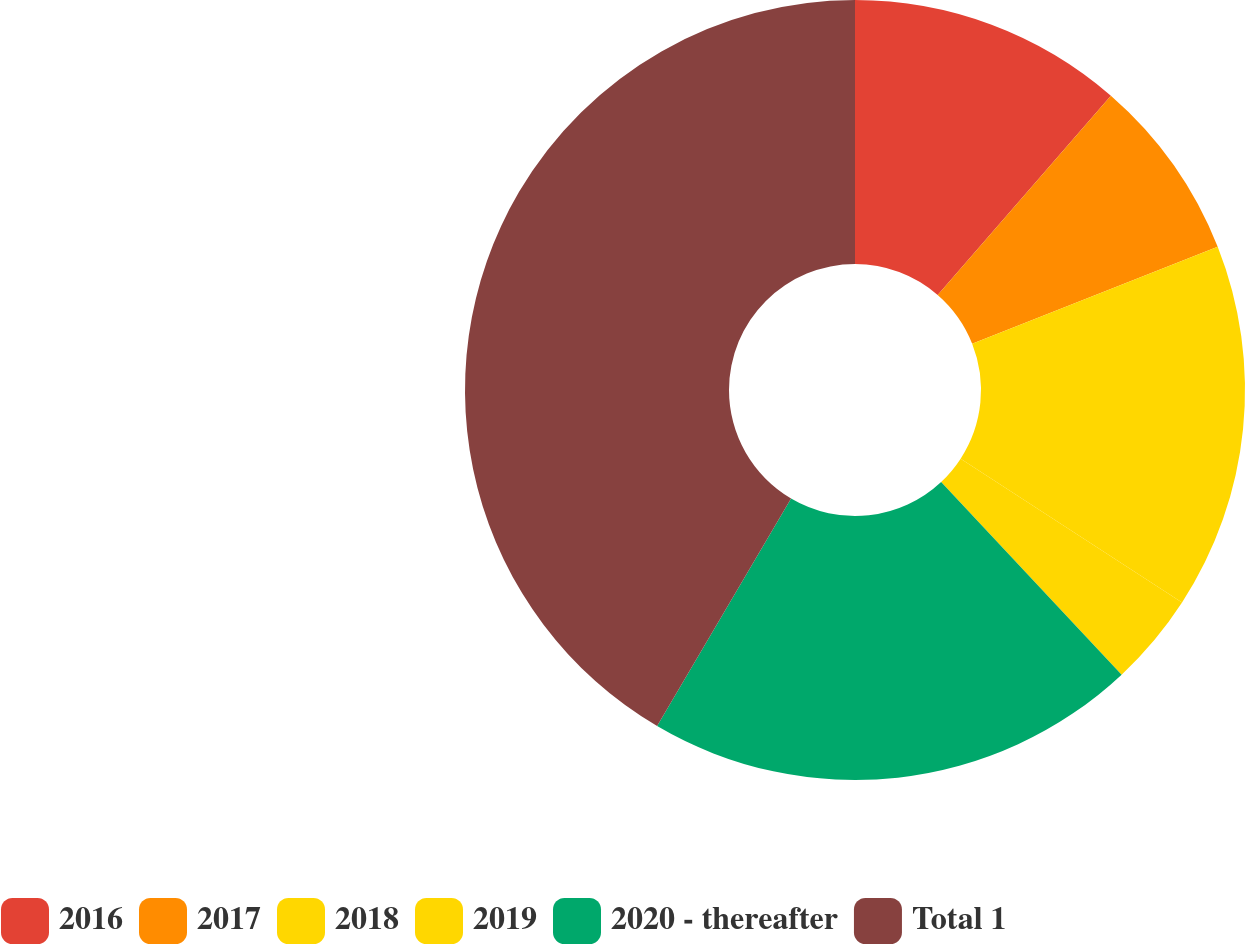<chart> <loc_0><loc_0><loc_500><loc_500><pie_chart><fcel>2016<fcel>2017<fcel>2018<fcel>2019<fcel>2020 - thereafter<fcel>Total 1<nl><fcel>11.39%<fcel>7.62%<fcel>15.16%<fcel>3.85%<fcel>20.45%<fcel>41.53%<nl></chart> 